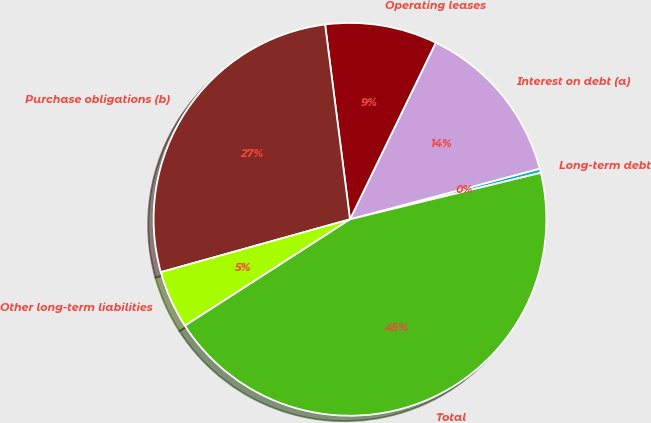Convert chart. <chart><loc_0><loc_0><loc_500><loc_500><pie_chart><fcel>Long-term debt<fcel>Interest on debt (a)<fcel>Operating leases<fcel>Purchase obligations (b)<fcel>Other long-term liabilities<fcel>Total<nl><fcel>0.35%<fcel>13.65%<fcel>9.22%<fcel>27.31%<fcel>4.78%<fcel>44.69%<nl></chart> 